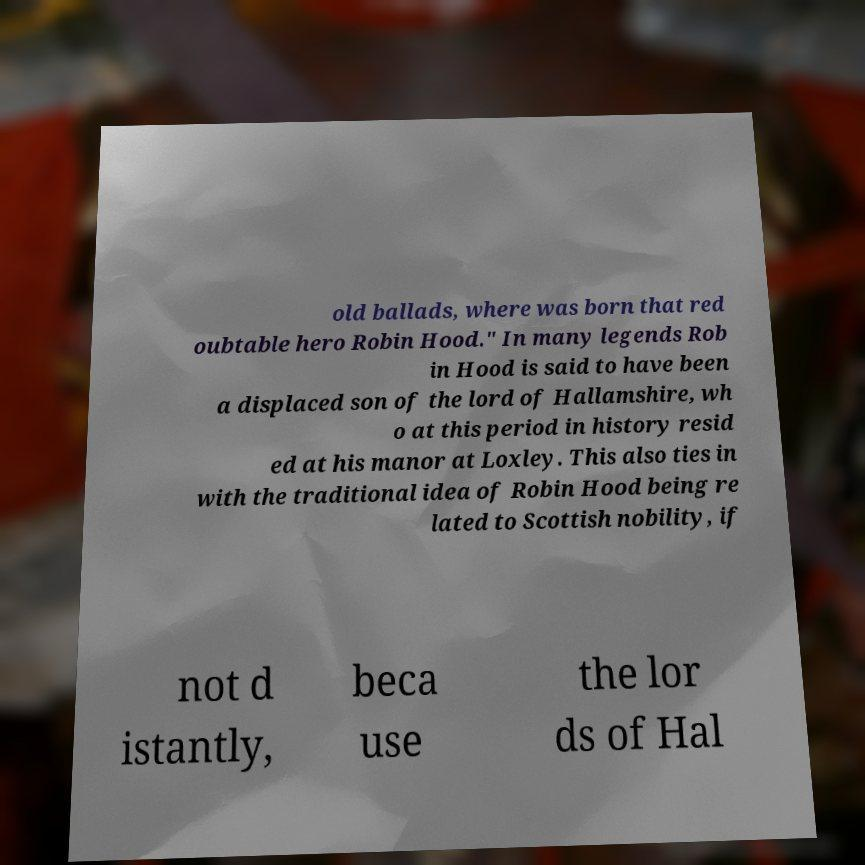I need the written content from this picture converted into text. Can you do that? old ballads, where was born that red oubtable hero Robin Hood." In many legends Rob in Hood is said to have been a displaced son of the lord of Hallamshire, wh o at this period in history resid ed at his manor at Loxley. This also ties in with the traditional idea of Robin Hood being re lated to Scottish nobility, if not d istantly, beca use the lor ds of Hal 